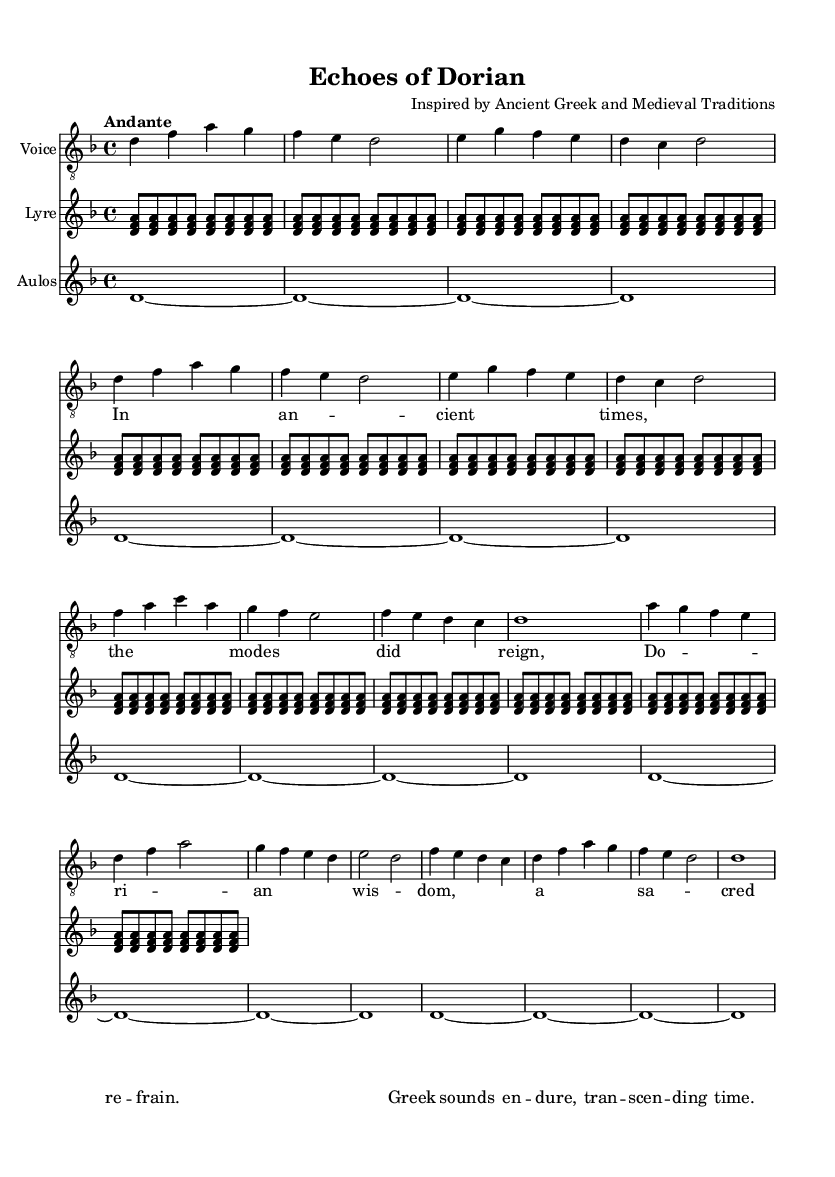What is the key signature of this music? The key signature is indicated right after the clef, which shows two flats. This corresponds to D minor.
Answer: D minor What is the time signature of this music? The time signature is displayed at the beginning of the score, indicating the piece is in 4/4 time, meaning there are four beats per measure.
Answer: 4/4 What tempo marking is given in this music? The tempo marking appears at the start of the score, stating "Andante," which suggests a moderately slow pace.
Answer: Andante How many sections are there in the score? By analyzing the structure of the score, we can identify three distinct sections: the Introduction, Verse 1, and the Interlude, alongside a Coda at the end.
Answer: Four What is the predominant instrument type in this music? The staves indicate various instruments used, but the primary one associated with the melodic line is the "Voice," as it carries the main melody with lyrics.
Answer: Voice What mode is predominantly reflected in this music? The title "Echoes of Dorian" suggests that the Dorian mode, which is the second mode of the major scale and characterized by a minor third and a major sixth, is primarily used in this piece.
Answer: Dorian What thematic element is present in the lyrics? The lyrics focus on ancient themes, specifically mentioning "ancient times" and "Greek sounds," which connects the piece to its historical influences.
Answer: Ancient themes 